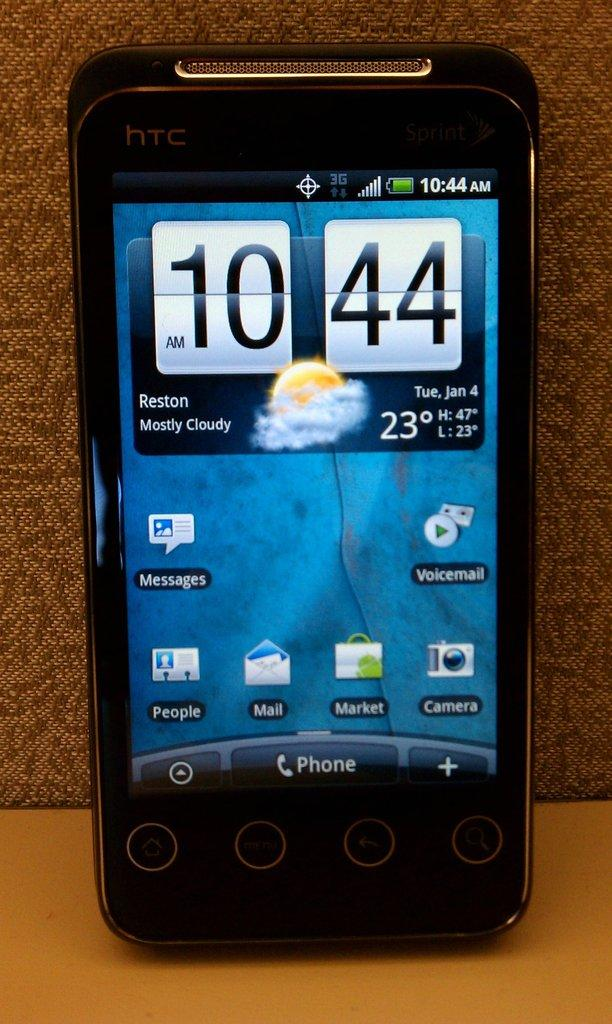<image>
Render a clear and concise summary of the photo. A cell phone displays the time 10:44 AM and a weather forecast of mostly cloudy. 